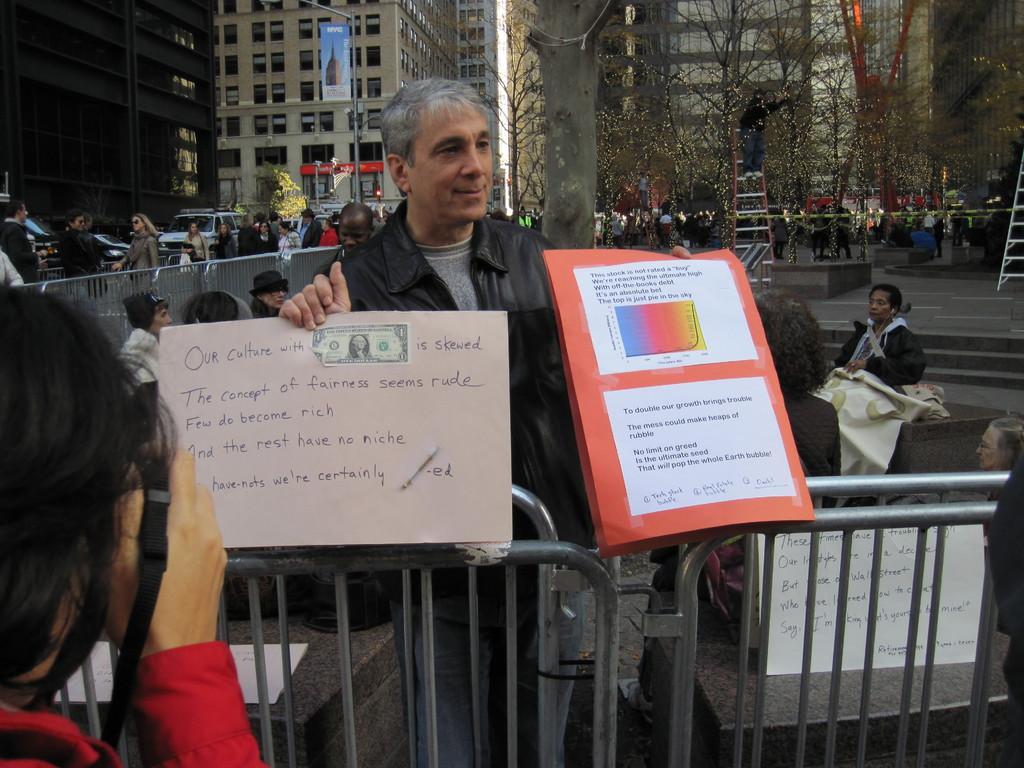How would you summarize this image in a sentence or two? There is a person on the left. There are fences. A person is standing holding chart papers. There are other people at the back. There are stairs, ladders, trees, poles and buildings. 